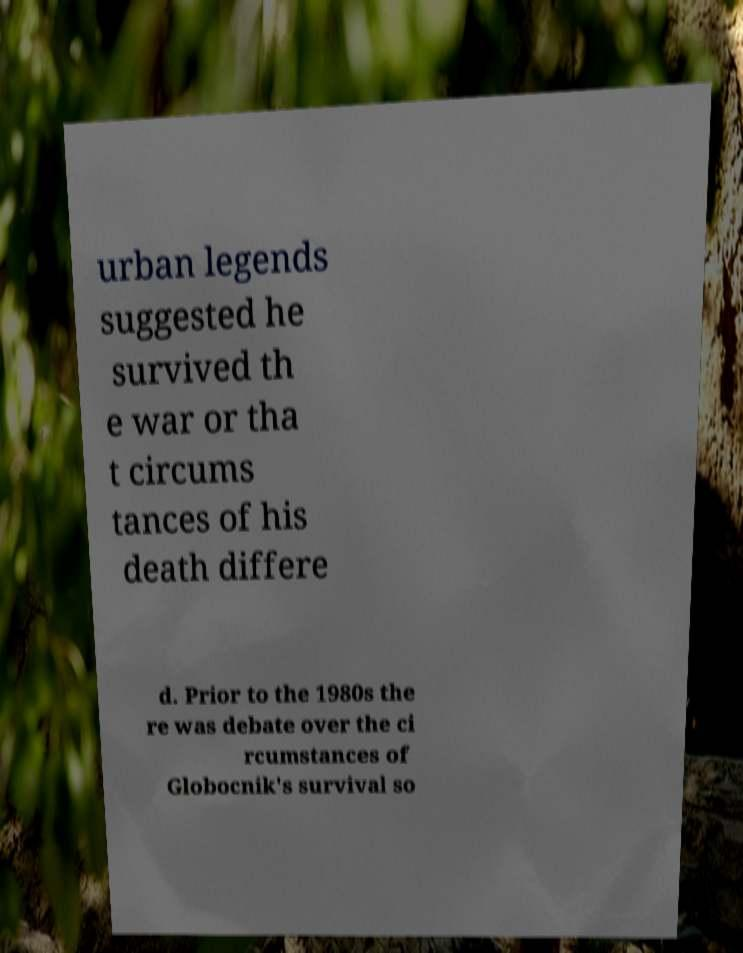Can you accurately transcribe the text from the provided image for me? urban legends suggested he survived th e war or tha t circums tances of his death differe d. Prior to the 1980s the re was debate over the ci rcumstances of Globocnik's survival so 